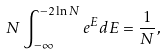Convert formula to latex. <formula><loc_0><loc_0><loc_500><loc_500>N \int _ { - \infty } ^ { - 2 \ln { N } } e ^ { E } d E = \frac { 1 } { N } ,</formula> 